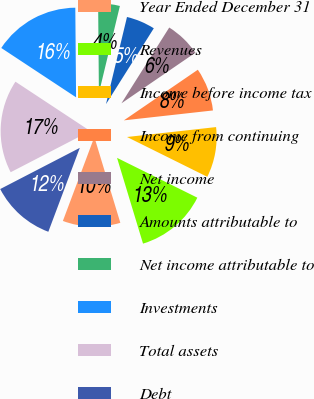Convert chart. <chart><loc_0><loc_0><loc_500><loc_500><pie_chart><fcel>Year Ended December 31<fcel>Revenues<fcel>Income before income tax<fcel>Income from continuing<fcel>Net income<fcel>Amounts attributable to<fcel>Net income attributable to<fcel>Investments<fcel>Total assets<fcel>Debt<nl><fcel>10.39%<fcel>12.99%<fcel>9.09%<fcel>7.79%<fcel>6.49%<fcel>5.19%<fcel>3.9%<fcel>15.58%<fcel>16.88%<fcel>11.69%<nl></chart> 